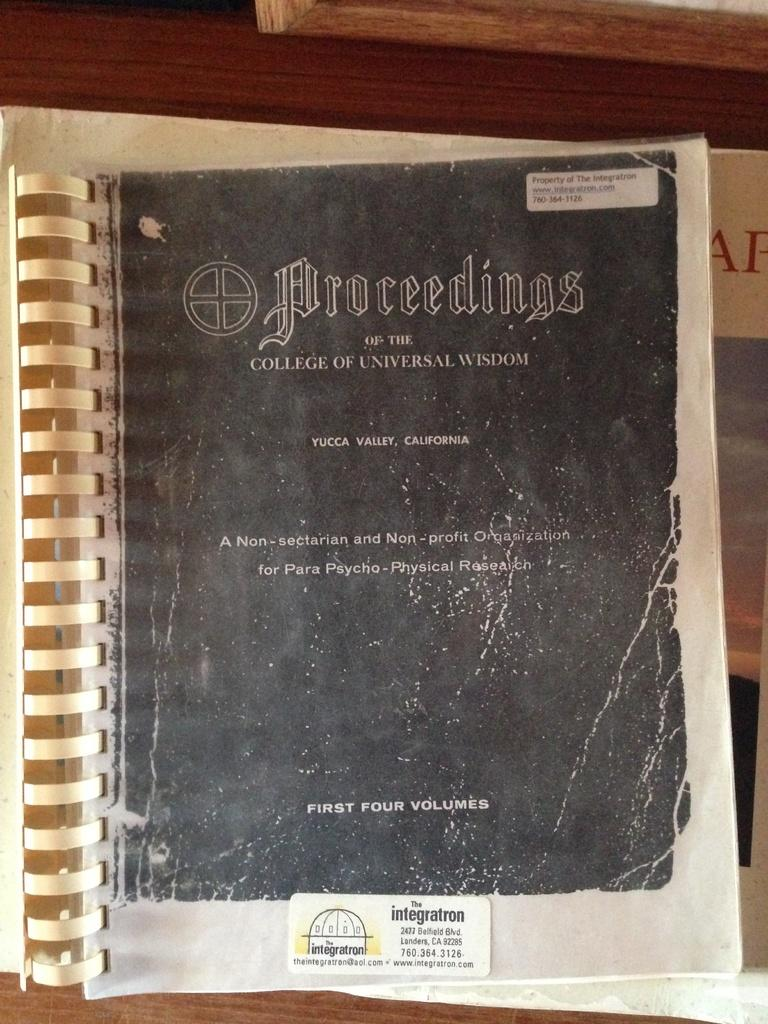<image>
Give a short and clear explanation of the subsequent image. Proceedings of the College of Universal Wisdom book 